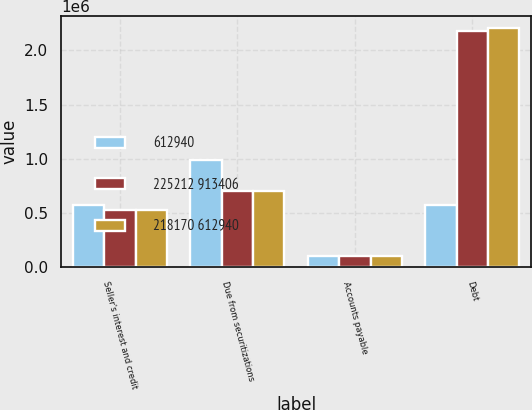<chart> <loc_0><loc_0><loc_500><loc_500><stacked_bar_chart><ecel><fcel>Seller's interest and credit<fcel>Due from securitizations<fcel>Accounts payable<fcel>Debt<nl><fcel>612940<fcel>574004<fcel>992523<fcel>103891<fcel>574004<nl><fcel>225212 913406<fcel>531594<fcel>701347<fcel>107209<fcel>2.18018e+06<nl><fcel>218170 612940<fcel>531594<fcel>701347<fcel>107209<fcel>2.20659e+06<nl></chart> 